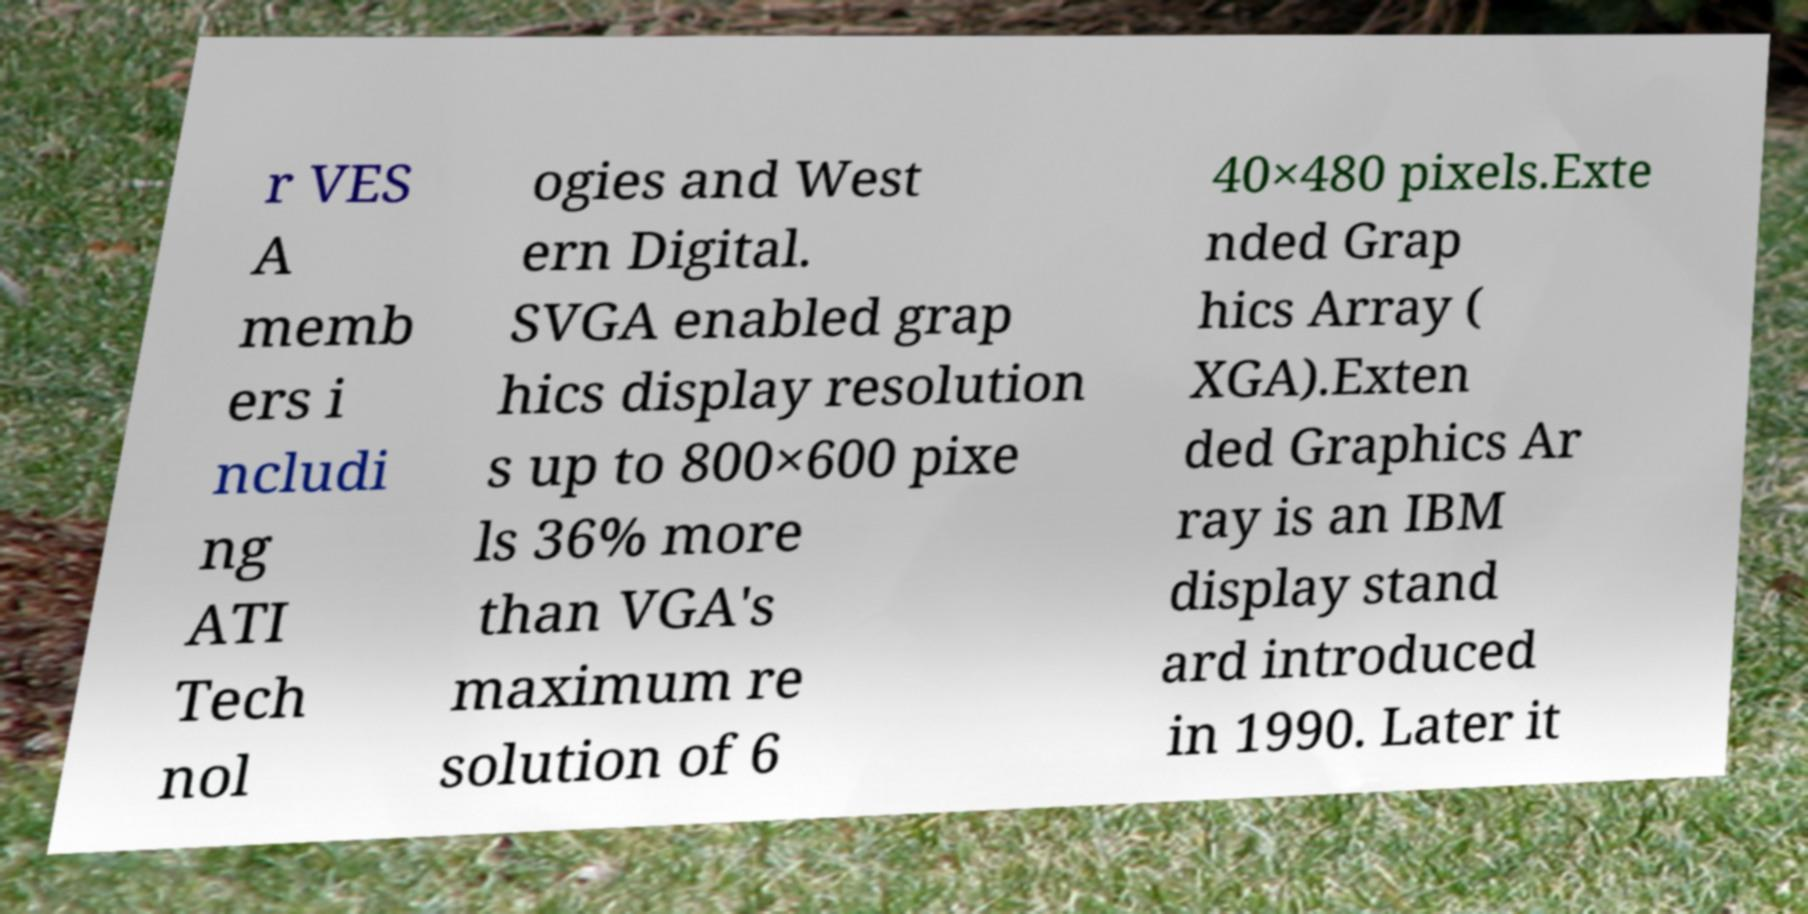For documentation purposes, I need the text within this image transcribed. Could you provide that? r VES A memb ers i ncludi ng ATI Tech nol ogies and West ern Digital. SVGA enabled grap hics display resolution s up to 800×600 pixe ls 36% more than VGA's maximum re solution of 6 40×480 pixels.Exte nded Grap hics Array ( XGA).Exten ded Graphics Ar ray is an IBM display stand ard introduced in 1990. Later it 